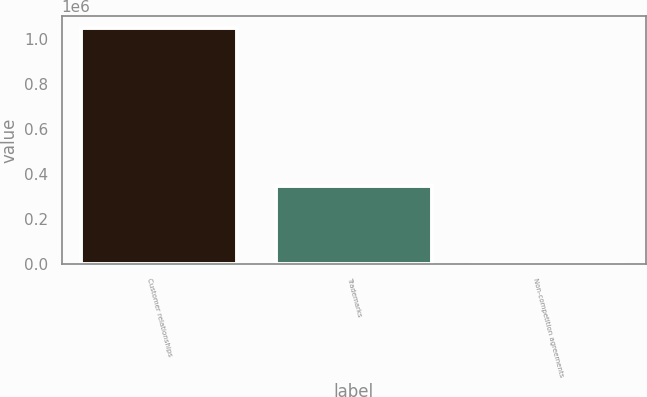<chart> <loc_0><loc_0><loc_500><loc_500><bar_chart><fcel>Customer relationships<fcel>Trademarks<fcel>Non-competition agreements<nl><fcel>1.05204e+06<fcel>346456<fcel>1894<nl></chart> 